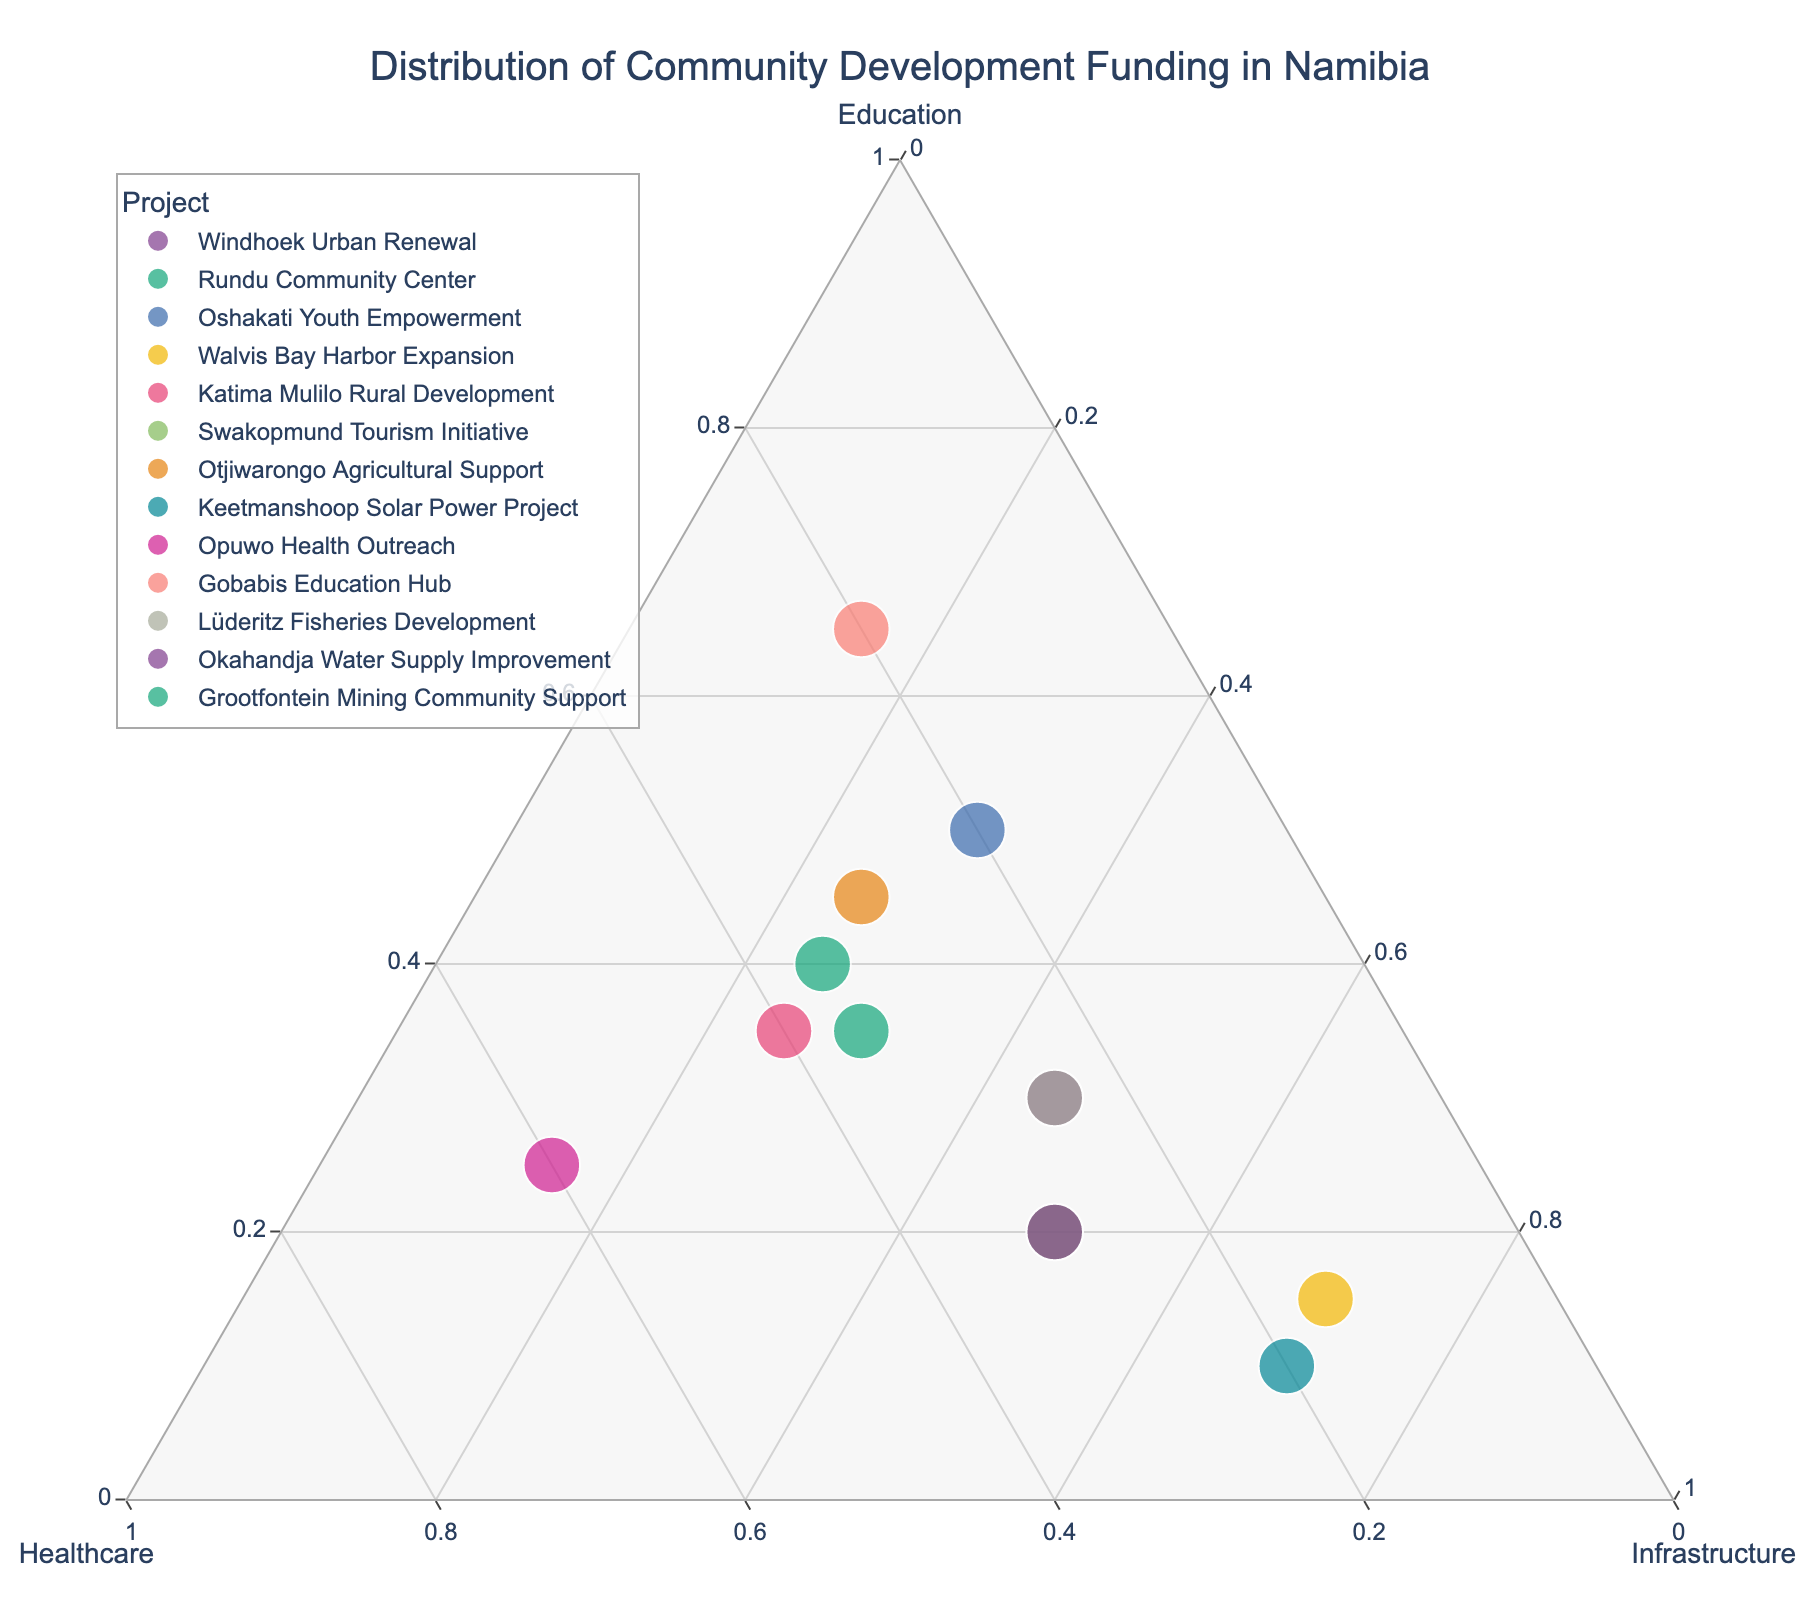What is the title of the plot? The title of the plot is typically at the top center of the chart. It provides a summary of what the chart is about. The title in this plot reads "Distribution of Community Development Funding in Namibia".
Answer: Distribution of Community Development Funding in Namibia How many data points are represented in the plot? To determine the number of data points in the plot, count the unique projects plotted. Each project corresponds to a unique data point. In this plot, there are 13 unique projects.
Answer: 13 Which project has the highest proportion of its funding allocated to Education? To answer this, we look at the vertices labeled “Education” to see which data point is closest to it. In this case, "Gobabis Education Hub" is closest, indicating the highest proportion of funding allocated to Education.
Answer: Gobabis Education Hub Which project has equal distribution of funding across all three sectors? To determine this, we look for a point that is equidistant from all three vertices (Education, Healthcare, Infrastructure), meaning it would be close to the center of the plot. From the plot, it’s evident that none of the projects have an equal distribution across all sectors.
Answer: None Which project allocates the most funding to Infrastructure? To find the project with the highest infrastructure allocation, look for the point closest to the "Infrastructure" vertex. In this plot, both "Walvis Bay Harbor Expansion" and "Keetmanshoop Solar Power Project" are closest to the Infrastructure vertex with 70% allocation each.
Answer: Walvis Bay Harbor Expansion and Keetmanshoop Solar Power Project Compared to Windhoek Urban Renewal, which project has a higher proportion of funding for Healthcare? By comparing the coordinates for Healthcare, we observe that "Opuwo Health Outreach" (60%) allocates more to healthcare compared to "Windhoek Urban Renewal" (25%).
Answer: Opuwo Health Outreach What is the total percentage of funds allocated to Education and Healthcare for Otjiwarongo Agricultural Support? Sum the normalized percentages of Education (45%) and Healthcare (30%) for "Otjiwarongo Agricultural Support". Adding these gives 45% + 30% = 75%.
Answer: 75% Which project is the closest to the intersection of Education (30%), Healthcare (30%), and Infrastructure (40%)? We look for the point that appears to be at that intersection in the plot. "Grootfontein Mining Community Support" is closest to these percentages.
Answer: Grootfontein Mining Community Support Rank the following projects by the proportion allocated to Healthcare from highest to lowest: "Swakopmund Tourism Initiative", "Rundu Community Center", "Katima Mulilo Rural Development". Based on their positions relative to the "Healthcare" vertex, we rank them as follows: "Katima Mulilo Rural Development" (40%) > "Rundu Community Center" (35%) > "Swakopmund Tourism Initiative" (30%).
Answer: Katima Mulilo Rural Development, Rundu Community Center, Swakopmund Tourism Initiative Which project has the lowest proportion of funding allocated to Infrastructure? By finding the point closest to the "Healthcare" and "Education" axis while furthest from "Infrastructure", we identify "Gobabis Education Hub" with only 15% allocated to Infrastructure.
Answer: Gobabis Education Hub 